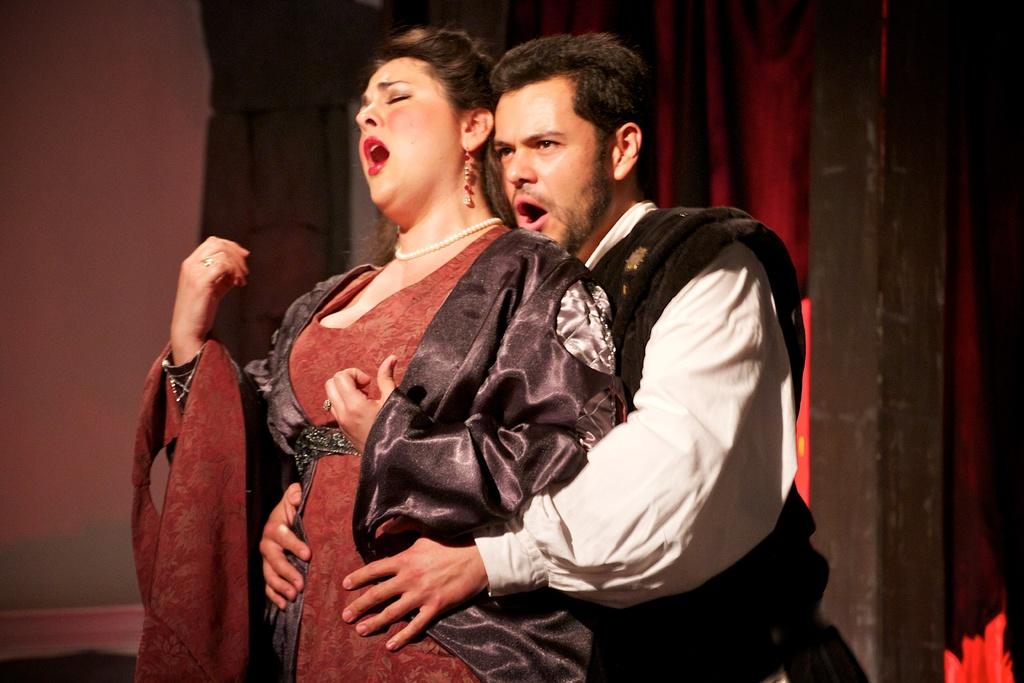How many people are present in the image? There are two persons standing in the image. Can you describe the objects in the background of the image? Unfortunately, the provided facts do not give any information about the objects in the background. What type of beef is being served on the silk tablecloth in the image? There is no beef or silk tablecloth present in the image. 